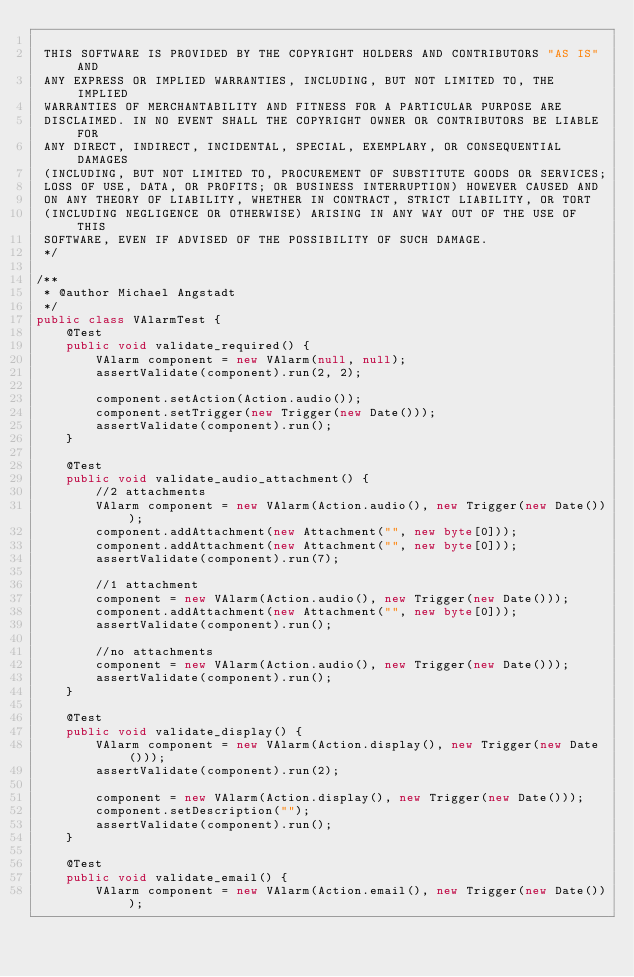Convert code to text. <code><loc_0><loc_0><loc_500><loc_500><_Java_>
 THIS SOFTWARE IS PROVIDED BY THE COPYRIGHT HOLDERS AND CONTRIBUTORS "AS IS" AND
 ANY EXPRESS OR IMPLIED WARRANTIES, INCLUDING, BUT NOT LIMITED TO, THE IMPLIED
 WARRANTIES OF MERCHANTABILITY AND FITNESS FOR A PARTICULAR PURPOSE ARE
 DISCLAIMED. IN NO EVENT SHALL THE COPYRIGHT OWNER OR CONTRIBUTORS BE LIABLE FOR
 ANY DIRECT, INDIRECT, INCIDENTAL, SPECIAL, EXEMPLARY, OR CONSEQUENTIAL DAMAGES
 (INCLUDING, BUT NOT LIMITED TO, PROCUREMENT OF SUBSTITUTE GOODS OR SERVICES;
 LOSS OF USE, DATA, OR PROFITS; OR BUSINESS INTERRUPTION) HOWEVER CAUSED AND
 ON ANY THEORY OF LIABILITY, WHETHER IN CONTRACT, STRICT LIABILITY, OR TORT
 (INCLUDING NEGLIGENCE OR OTHERWISE) ARISING IN ANY WAY OUT OF THE USE OF THIS
 SOFTWARE, EVEN IF ADVISED OF THE POSSIBILITY OF SUCH DAMAGE.
 */

/**
 * @author Michael Angstadt
 */
public class VAlarmTest {
	@Test
	public void validate_required() {
		VAlarm component = new VAlarm(null, null);
		assertValidate(component).run(2, 2);

		component.setAction(Action.audio());
		component.setTrigger(new Trigger(new Date()));
		assertValidate(component).run();
	}

	@Test
	public void validate_audio_attachment() {
		//2 attachments
		VAlarm component = new VAlarm(Action.audio(), new Trigger(new Date()));
		component.addAttachment(new Attachment("", new byte[0]));
		component.addAttachment(new Attachment("", new byte[0]));
		assertValidate(component).run(7);

		//1 attachment
		component = new VAlarm(Action.audio(), new Trigger(new Date()));
		component.addAttachment(new Attachment("", new byte[0]));
		assertValidate(component).run();

		//no attachments
		component = new VAlarm(Action.audio(), new Trigger(new Date()));
		assertValidate(component).run();
	}

	@Test
	public void validate_display() {
		VAlarm component = new VAlarm(Action.display(), new Trigger(new Date()));
		assertValidate(component).run(2);

		component = new VAlarm(Action.display(), new Trigger(new Date()));
		component.setDescription("");
		assertValidate(component).run();
	}

	@Test
	public void validate_email() {
		VAlarm component = new VAlarm(Action.email(), new Trigger(new Date()));</code> 